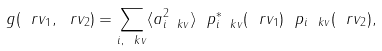Convert formula to latex. <formula><loc_0><loc_0><loc_500><loc_500>g ( \ r v _ { 1 } , \ r v _ { 2 } ) = \sum _ { i , \ k v } \langle a _ { i \ k v } ^ { 2 } \rangle \ p _ { i \ k v } ^ { * } ( \ r v _ { 1 } ) \ p _ { i \ k v } ( \ r v _ { 2 } ) ,</formula> 